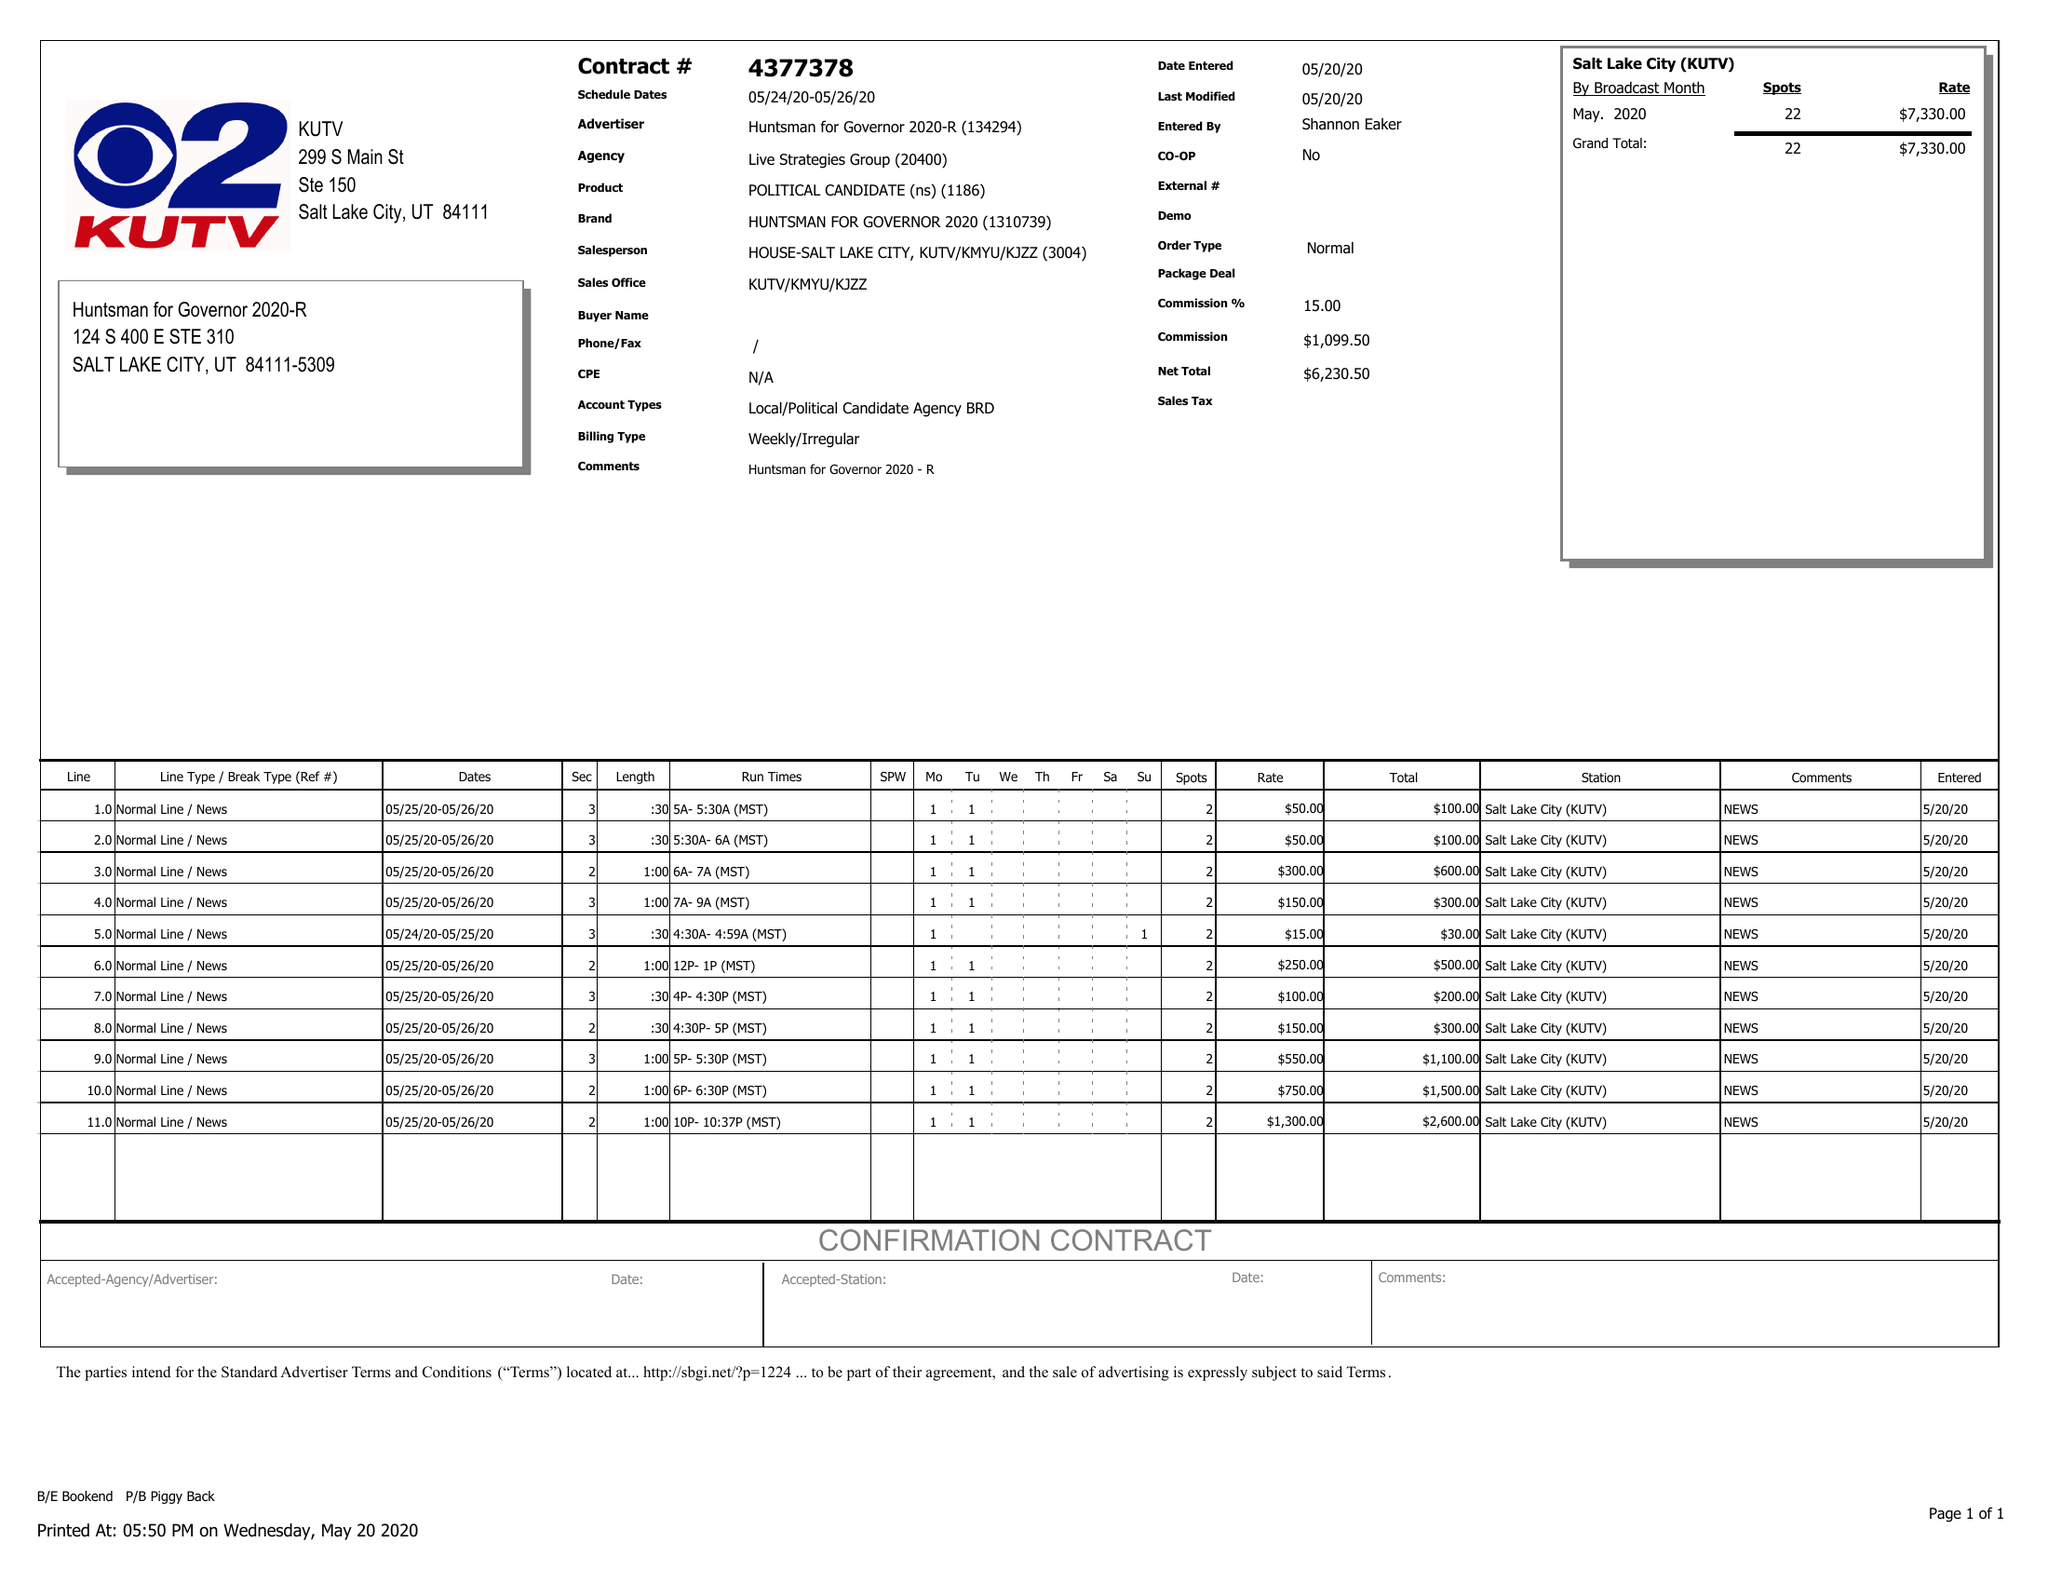What is the value for the advertiser?
Answer the question using a single word or phrase. LIVE STRATEGIES GROUP 